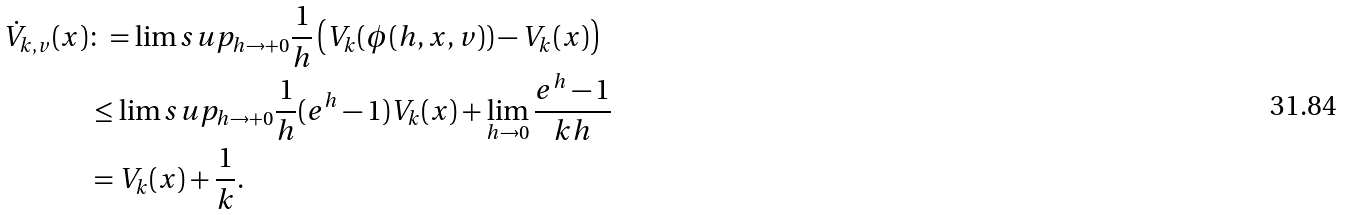Convert formula to latex. <formula><loc_0><loc_0><loc_500><loc_500>\dot { V } _ { k , v } ( x ) & \colon = \lim s u p _ { h \to + 0 } \frac { 1 } { h } \left ( V _ { k } ( \phi ( h , x , v ) ) - V _ { k } ( x ) \right ) \\ & \leq \lim s u p _ { h \to + 0 } \frac { 1 } { h } ( e ^ { h } - 1 ) V _ { k } ( x ) + \lim _ { h \to 0 } \frac { e ^ { h } - 1 } { k h } \\ & = V _ { k } ( x ) + \frac { 1 } { k } .</formula> 